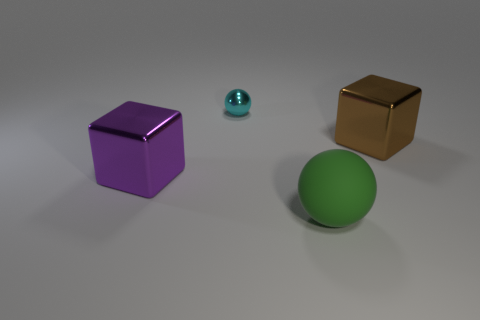Add 2 big brown cubes. How many objects exist? 6 Subtract 1 blocks. How many blocks are left? 1 Subtract all purple blocks. How many blocks are left? 1 Subtract all large brown blocks. Subtract all matte things. How many objects are left? 2 Add 2 cyan things. How many cyan things are left? 3 Add 4 small green blocks. How many small green blocks exist? 4 Subtract 0 brown cylinders. How many objects are left? 4 Subtract all cyan spheres. Subtract all green cubes. How many spheres are left? 1 Subtract all gray balls. How many gray blocks are left? 0 